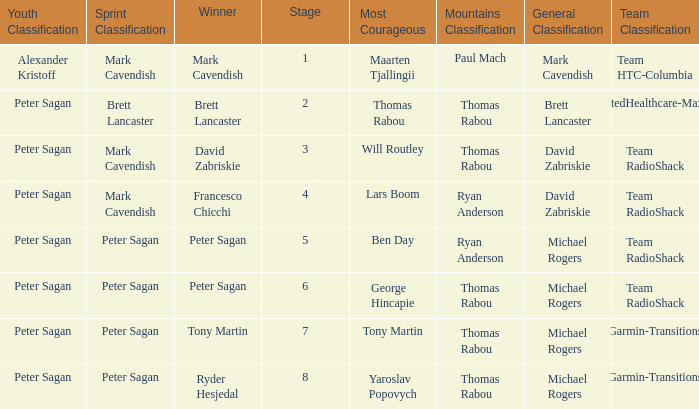When Ryan Anderson won the mountains classification, and Michael Rogers won the general classification, who won the sprint classification? Peter Sagan. 